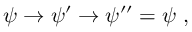<formula> <loc_0><loc_0><loc_500><loc_500>\psi \rightarrow \psi ^ { \prime } \rightarrow \psi ^ { \prime \prime } = \psi ,</formula> 